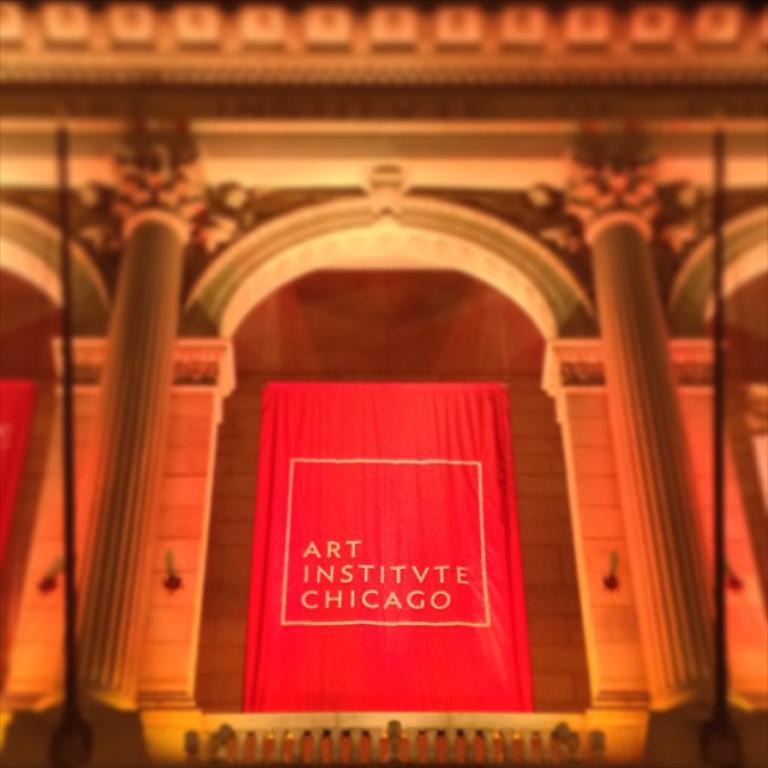What type of structure is present in the image? There is a building in the image. What architectural features can be seen on the building? There are pillars visible on the building. What type of covering is present in the image? There is a curtain in the image. What can be read or seen in the form of text in the image? There is text visible on the image. How would you describe the background of the image? The background of the image is blurred. Where is the nest located in the image? There is no nest present in the image. How many rings can be seen on the building in the image? There is no mention of rings in the image; the building has pillars instead. 